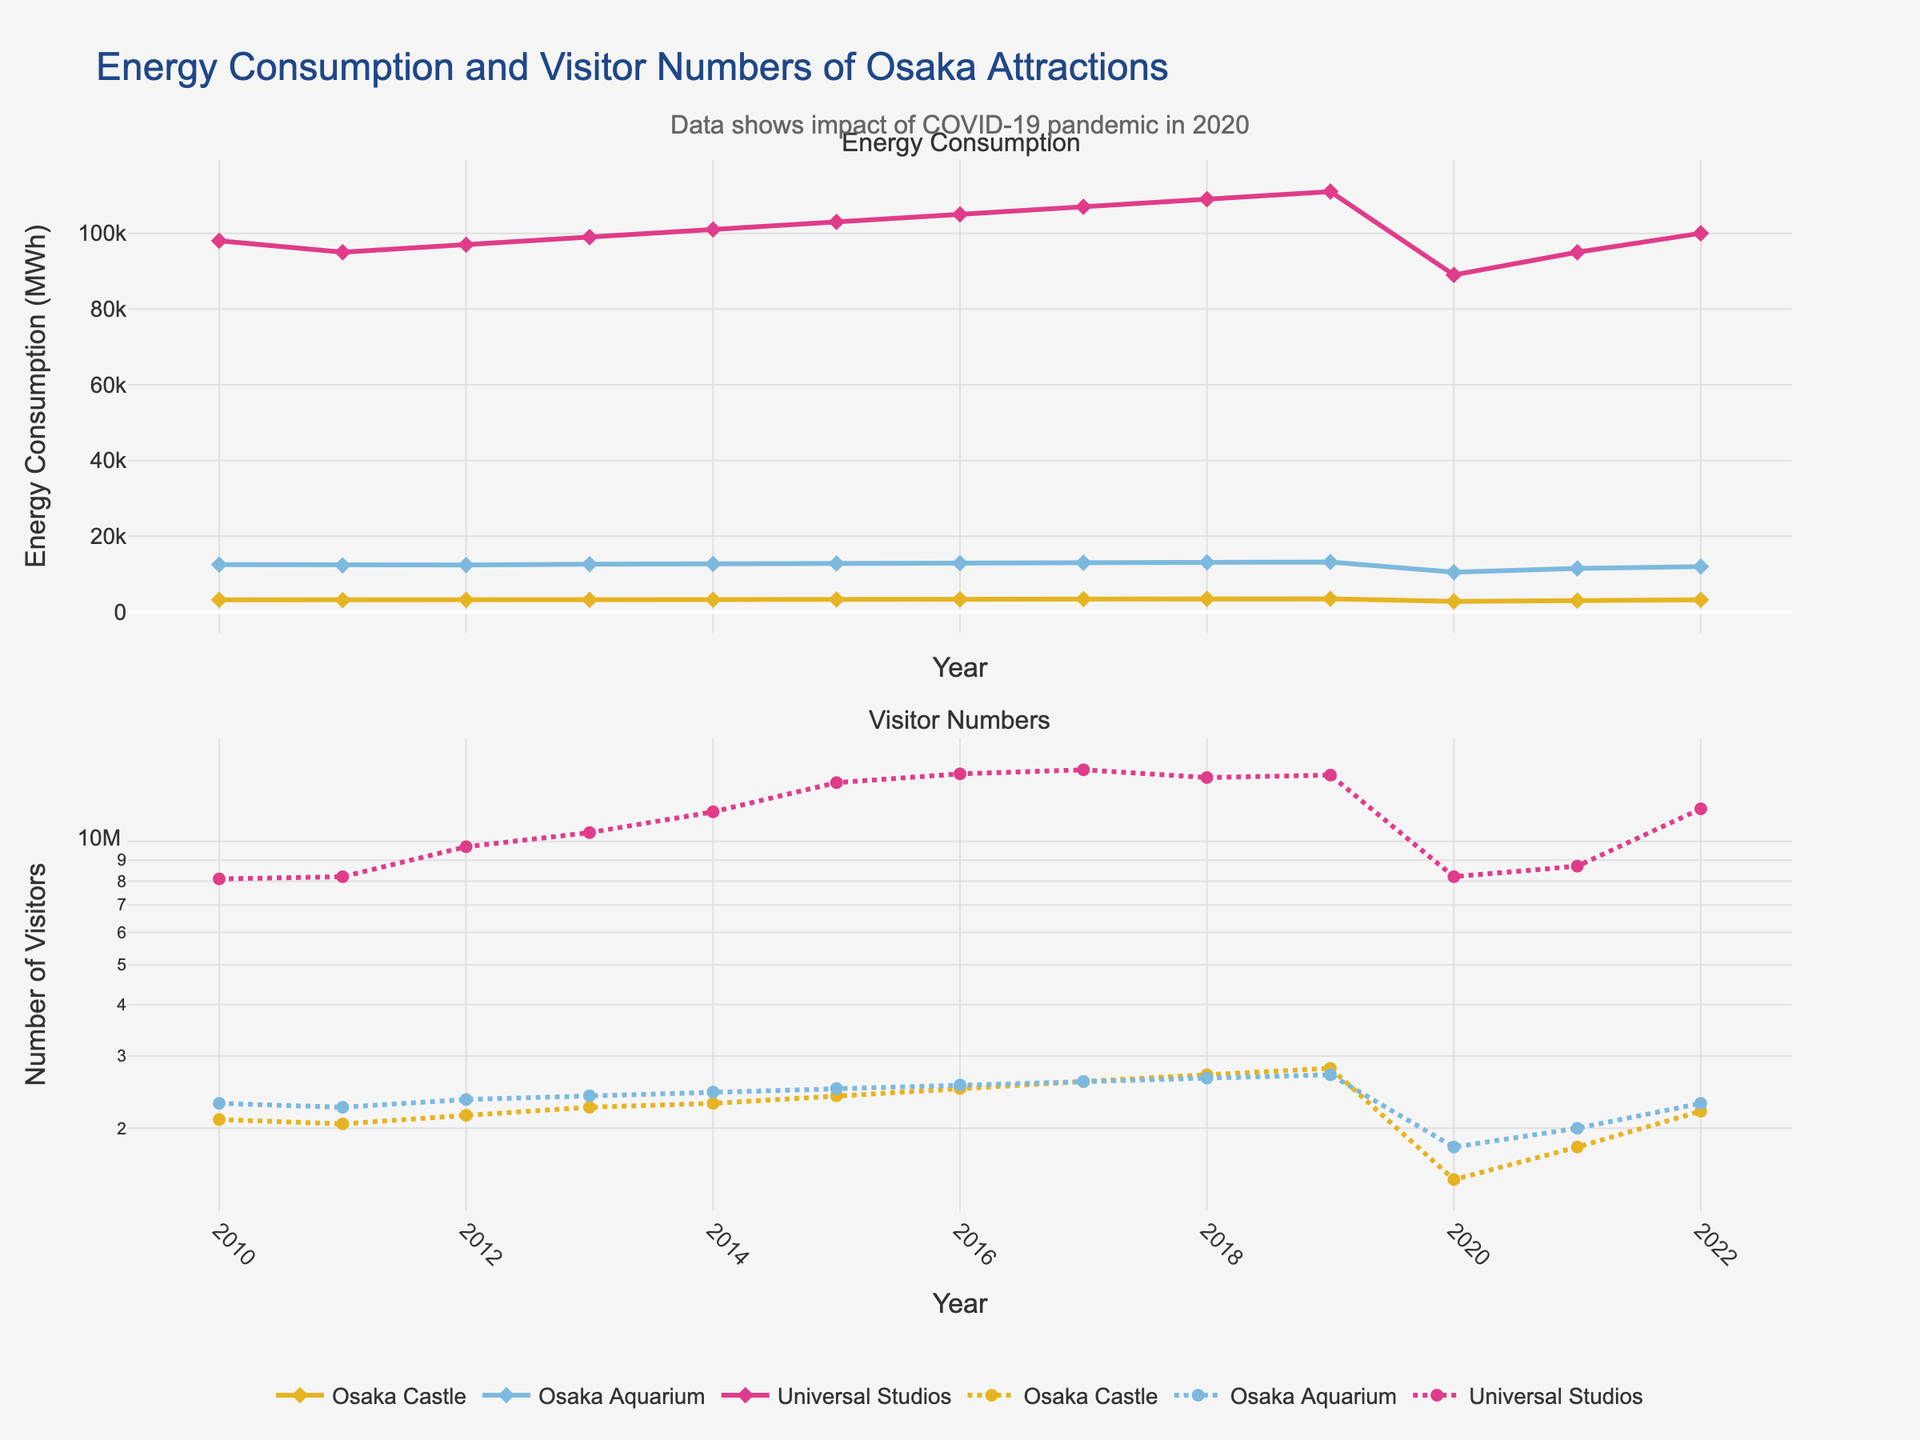What happened to the energy consumption and visitor numbers of Universal Studios Japan in 2020? The energy consumption and visitor numbers for Universal Studios Japan sharply decreased in 2020 compared to previous years. This can be attributed to the impact of COVID-19 which resulted in fewer visitors, and subsequently, lower energy consumption. For energy consumption, it decreased from around 111,000 MWh in 2019 to around 89,000 MWh in 2020. Similarly, visitor numbers decreased from around 14,500,000 in 2019 to around 8,200,000 in 2020.
Answer: Both decreased significantly Which attraction had the highest energy consumption in 2021? To determine the attraction with the highest energy consumption in 2021, we compare the values for that year: Osaka Castle (3000 MWh), Osaka Aquarium (11500 MWh), and Universal Studios Japan (95000 MWh). The highest among these is 95000 MWh for Universal Studios Japan.
Answer: Universal Studios Japan Between 2010 and 2019, how does the increase in visitor numbers for Osaka Castle compare to Osaka Aquarium? First, determine the visitor numbers in 2010 and 2019: Osaka Castle (2,100,000 to 2,800,000) and Osaka Aquarium (2,300,000 to 2,700,000). Subtract to find the increase: 700,000 for Osaka Castle and 400,000 for Osaka Aquarium. Therefore, Osaka Castle had a larger increase in visitor numbers.
Answer: Osaka Castle had a larger increase What is the average annual energy consumption of the Osaka Aquarium from 2010 to 2022? Sum the annual energy consumptions from 2010 to 2022 for Osaka Aquarium: 12500 + 12300 + 12400 + 12600 + 12700 + 12800 + 12900 + 13000 + 13100 + 13200 + 10500 + 11500 + 12000. The total is 167500. Divide by the number of years (13) to get the average: 167500 / 13 ≈ 12,885 MWh.
Answer: Approximately 12,885 MWh Compare the trend of visitor numbers for all attractions after 2019. From the chart, it's observable that visitor numbers for all attractions dropped significantly in 2020 due to the COVID-19 pandemic. For Osaka Castle, it went from around 2,800,000 in 2019 to 1,500,000 in 2020. For Osaka Aquarium, it dropped from around 2,700,000 to 1,800,000, and for Universal Studios Japan, from around 14,500,000 to around 8,200,000. In subsequent years, they began to recover but have not yet reached the pre-2020 levels.
Answer: All decreased significantly in 2020 and started to recover afterward Which year showed a notable increase in both energy consumption and visitor numbers for all attractions simultaneously? Observing the line plots, the year 2017 shows a noticeable increase in both energy consumption and visitor numbers for all attractions compared to previous years. All three lines in both subplots move upward more noticeably in 2017.
Answer: 2017 What is the difference in energy consumption between Universal Studios Japan and Osaka Castle in 2022? Universal Studios Japan's energy consumption in 2022 is 100,000 MWh and Osaka Castle's consumption is 3,200 MWh. Subtracting these two values gives: 100,000 - 3,200 = 96,800 MWh.
Answer: 96,800 MWh What is the proportion of Osaka Aquarium's visitors to Universal Studios Japan's visitors in 2018? In 2018, Osaka Aquarium had 2,650,000 visitors, and Universal Studios Japan had 14,300,000 visitors. The proportion is calculated as 2,650,000 / 14,300,000 ≈ 0.185 or approximately 18.5%.
Answer: Approximately 18.5% 